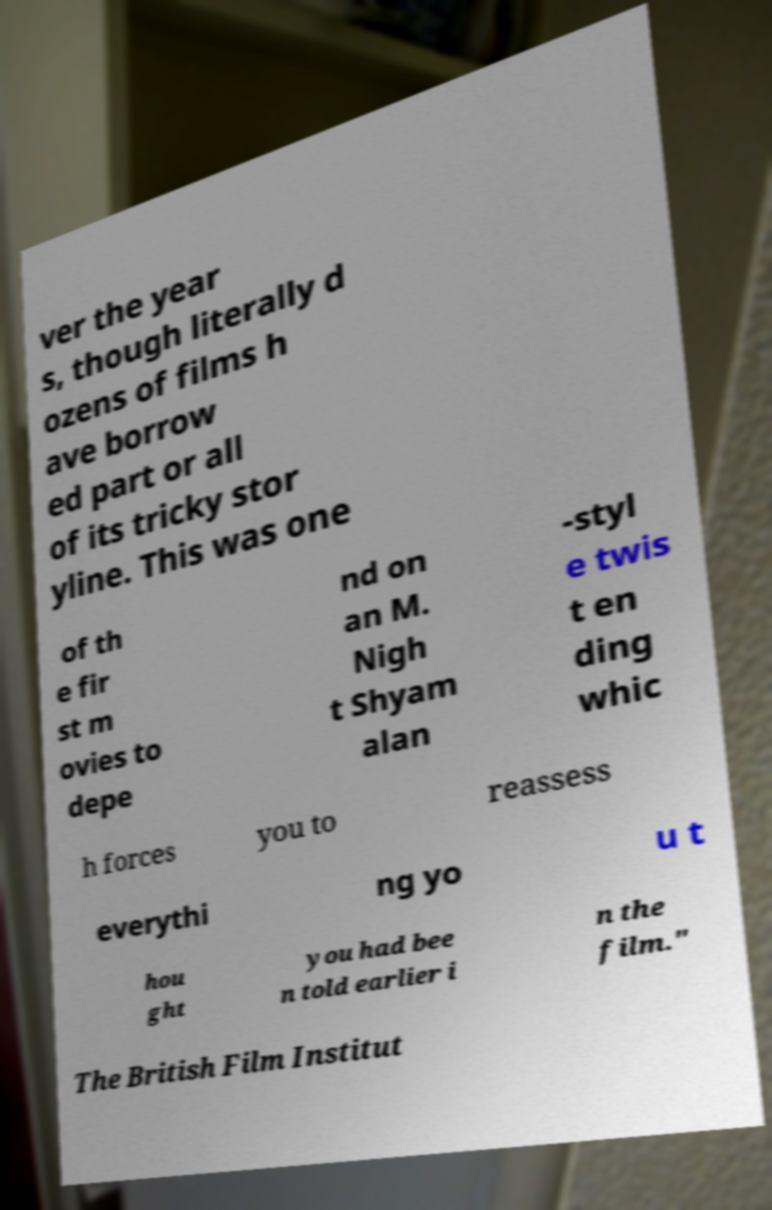There's text embedded in this image that I need extracted. Can you transcribe it verbatim? ver the year s, though literally d ozens of films h ave borrow ed part or all of its tricky stor yline. This was one of th e fir st m ovies to depe nd on an M. Nigh t Shyam alan -styl e twis t en ding whic h forces you to reassess everythi ng yo u t hou ght you had bee n told earlier i n the film." The British Film Institut 